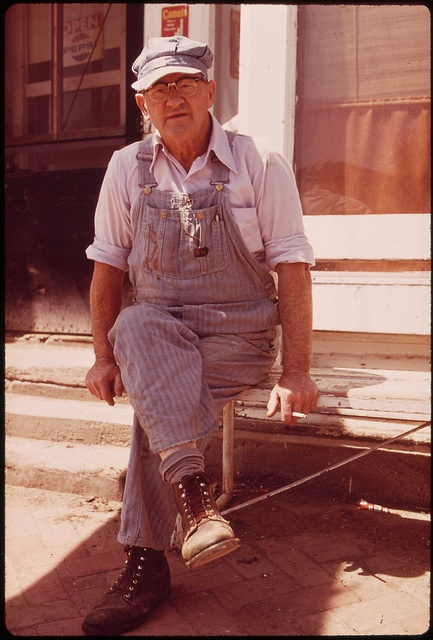Describe the objects in this image and their specific colors. I can see people in black, brown, maroon, and lightpink tones and bench in black, lightgray, brown, maroon, and tan tones in this image. 